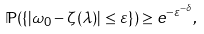Convert formula to latex. <formula><loc_0><loc_0><loc_500><loc_500>\mathbb { P } ( \{ | \omega _ { 0 } - \zeta ( \lambda ) | \leq \varepsilon \} ) \geq e ^ { - \varepsilon ^ { - \delta } } ,</formula> 